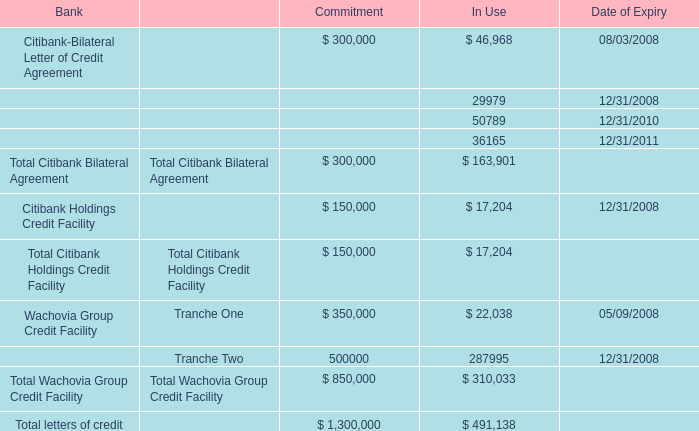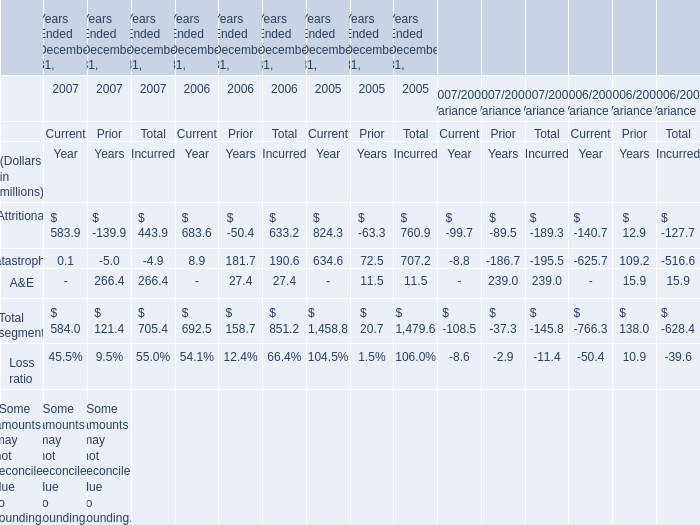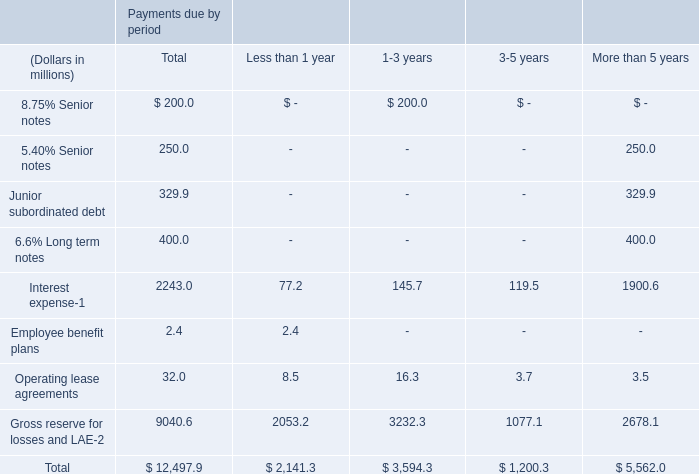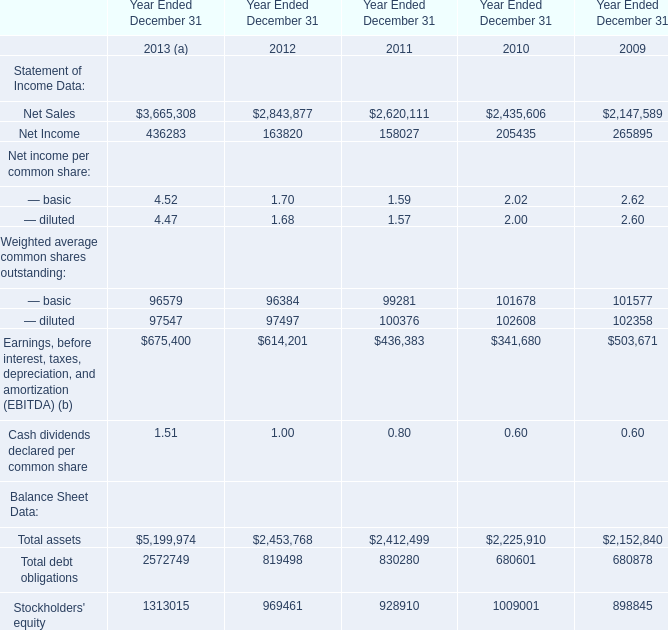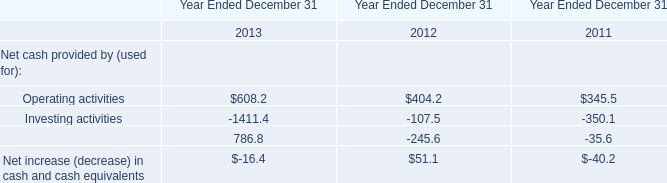what's the total amount of Wachovia Group Credit Facility of Commitment is, and Net Sales of Year Ended December 31 2012 ? 
Computations: (350000.0 + 2843877.0)
Answer: 3193877.0. 